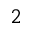<formula> <loc_0><loc_0><loc_500><loc_500>^ { 2 }</formula> 